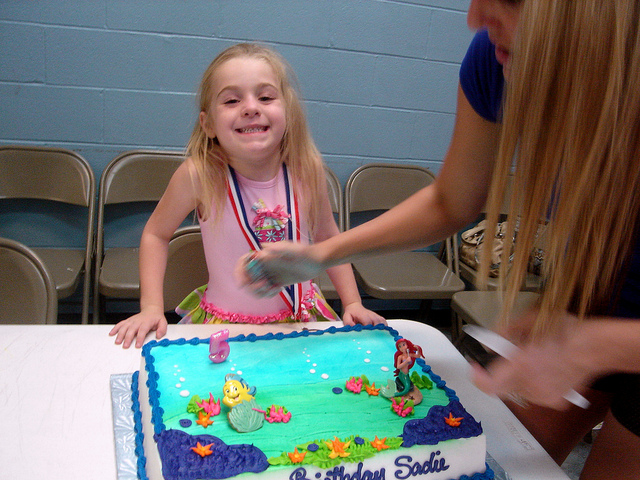<image>What does the writing say on the cake? I don't know what the writing on the cake exactly says. It could say 'birthday sadie', 'fishes', or 'happy birthday sadie'. What does the writing say on the cake? I am not sure what the writing says on the cake. It can be seen 'birthday sadie', 'fishes' or 'happy birthday sadie'. 